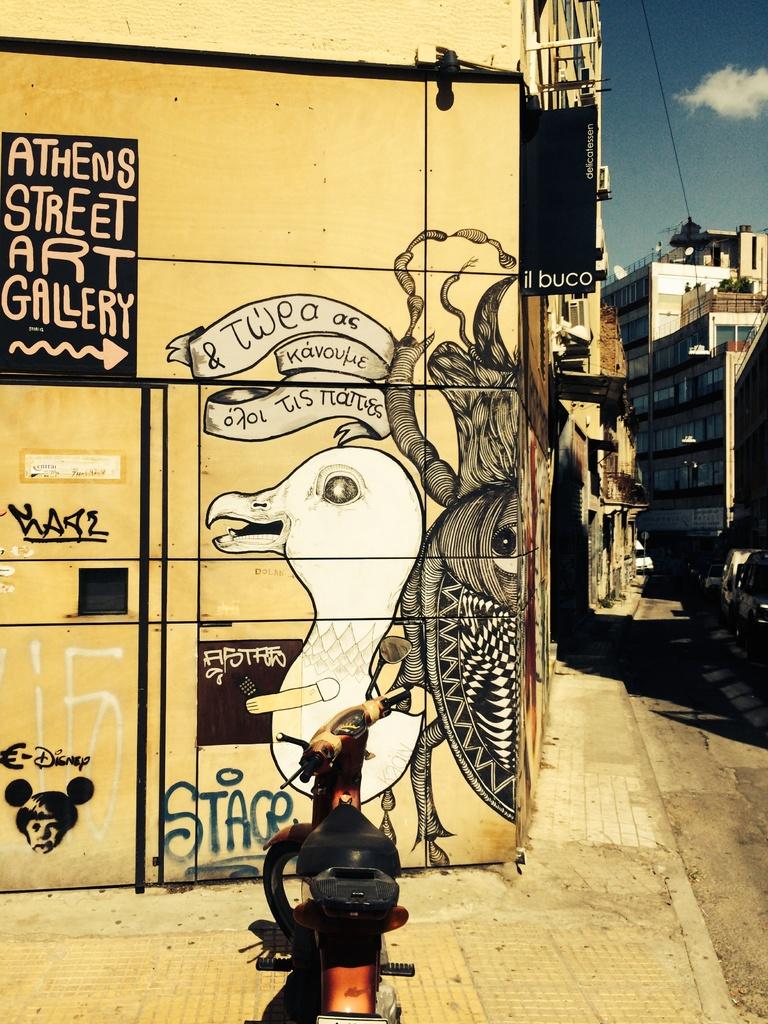What type of gallery is this?
Give a very brief answer. Art. Below the gull, what is written in green?
Your response must be concise. Stage. 